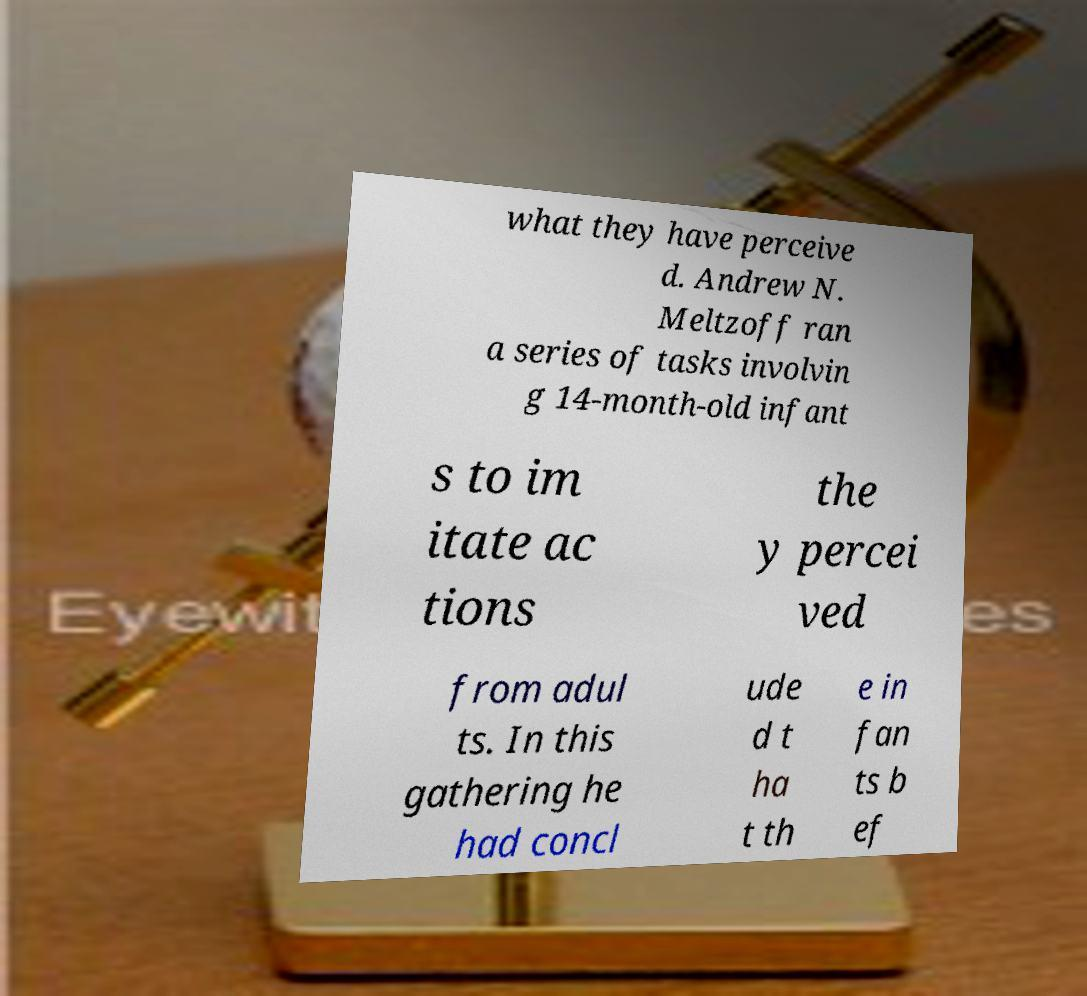Could you extract and type out the text from this image? what they have perceive d. Andrew N. Meltzoff ran a series of tasks involvin g 14-month-old infant s to im itate ac tions the y percei ved from adul ts. In this gathering he had concl ude d t ha t th e in fan ts b ef 